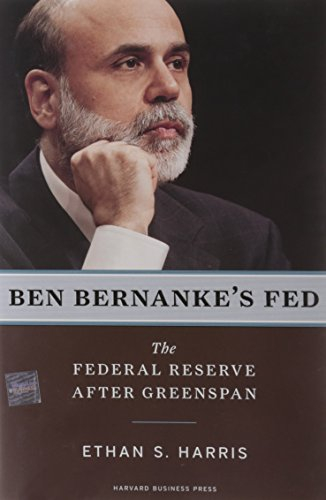What qualifications does Ethan S. Harris have for writing on this subject? Ethan S. Harris is an esteemed economist with extensive experience in financial markets and economic research, making him well-qualified to write on Federal Reserve policies and leadership. 